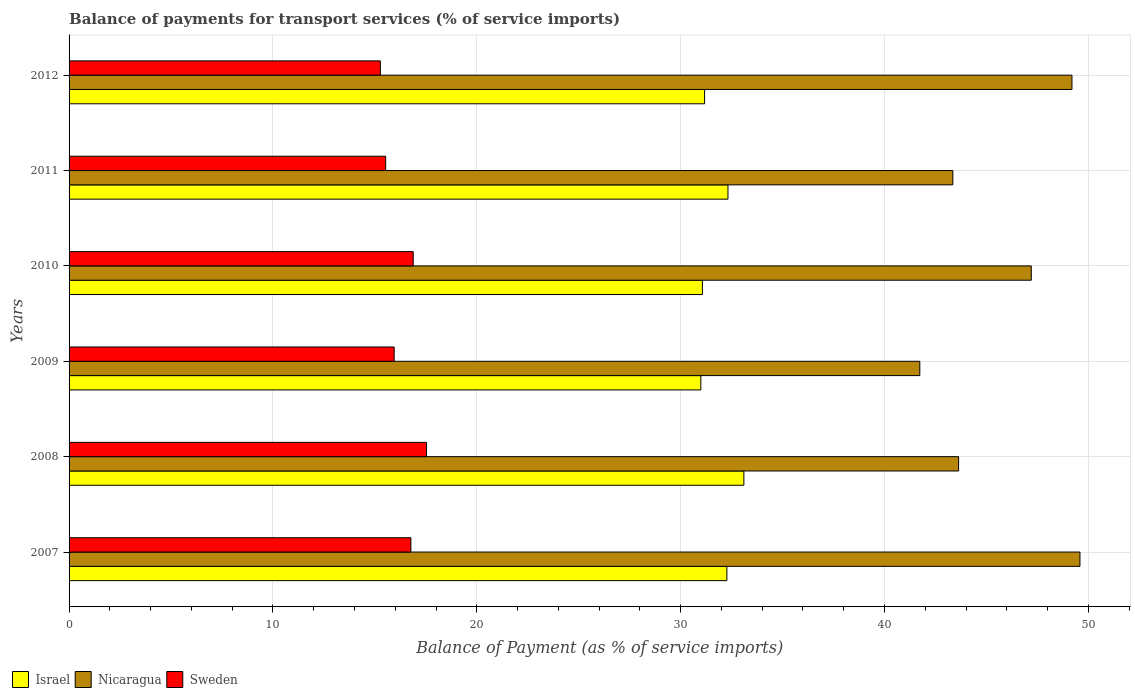How many different coloured bars are there?
Ensure brevity in your answer.  3. Are the number of bars per tick equal to the number of legend labels?
Your response must be concise. Yes. Are the number of bars on each tick of the Y-axis equal?
Give a very brief answer. Yes. How many bars are there on the 3rd tick from the top?
Your answer should be compact. 3. How many bars are there on the 5th tick from the bottom?
Provide a succinct answer. 3. What is the label of the 3rd group of bars from the top?
Offer a terse response. 2010. What is the balance of payments for transport services in Israel in 2010?
Make the answer very short. 31.07. Across all years, what is the maximum balance of payments for transport services in Israel?
Make the answer very short. 33.1. Across all years, what is the minimum balance of payments for transport services in Sweden?
Ensure brevity in your answer.  15.27. In which year was the balance of payments for transport services in Israel maximum?
Make the answer very short. 2008. What is the total balance of payments for transport services in Sweden in the graph?
Ensure brevity in your answer.  97.93. What is the difference between the balance of payments for transport services in Sweden in 2010 and that in 2011?
Make the answer very short. 1.35. What is the difference between the balance of payments for transport services in Nicaragua in 2010 and the balance of payments for transport services in Israel in 2008?
Provide a succinct answer. 14.1. What is the average balance of payments for transport services in Nicaragua per year?
Your response must be concise. 45.78. In the year 2012, what is the difference between the balance of payments for transport services in Nicaragua and balance of payments for transport services in Israel?
Your answer should be very brief. 18.02. In how many years, is the balance of payments for transport services in Nicaragua greater than 6 %?
Offer a terse response. 6. What is the ratio of the balance of payments for transport services in Sweden in 2007 to that in 2011?
Your response must be concise. 1.08. What is the difference between the highest and the second highest balance of payments for transport services in Nicaragua?
Keep it short and to the point. 0.39. What is the difference between the highest and the lowest balance of payments for transport services in Sweden?
Provide a succinct answer. 2.26. Is the sum of the balance of payments for transport services in Sweden in 2008 and 2009 greater than the maximum balance of payments for transport services in Israel across all years?
Make the answer very short. Yes. What does the 1st bar from the top in 2008 represents?
Offer a terse response. Sweden. What does the 2nd bar from the bottom in 2009 represents?
Provide a short and direct response. Nicaragua. Is it the case that in every year, the sum of the balance of payments for transport services in Sweden and balance of payments for transport services in Israel is greater than the balance of payments for transport services in Nicaragua?
Provide a short and direct response. No. How many bars are there?
Keep it short and to the point. 18. Are all the bars in the graph horizontal?
Give a very brief answer. Yes. How many years are there in the graph?
Give a very brief answer. 6. Are the values on the major ticks of X-axis written in scientific E-notation?
Your answer should be compact. No. What is the title of the graph?
Give a very brief answer. Balance of payments for transport services (% of service imports). Does "Thailand" appear as one of the legend labels in the graph?
Make the answer very short. No. What is the label or title of the X-axis?
Your answer should be very brief. Balance of Payment (as % of service imports). What is the Balance of Payment (as % of service imports) of Israel in 2007?
Give a very brief answer. 32.27. What is the Balance of Payment (as % of service imports) in Nicaragua in 2007?
Ensure brevity in your answer.  49.59. What is the Balance of Payment (as % of service imports) of Sweden in 2007?
Your response must be concise. 16.77. What is the Balance of Payment (as % of service imports) in Israel in 2008?
Provide a short and direct response. 33.1. What is the Balance of Payment (as % of service imports) in Nicaragua in 2008?
Keep it short and to the point. 43.63. What is the Balance of Payment (as % of service imports) in Sweden in 2008?
Your response must be concise. 17.54. What is the Balance of Payment (as % of service imports) of Israel in 2009?
Provide a succinct answer. 30.99. What is the Balance of Payment (as % of service imports) of Nicaragua in 2009?
Keep it short and to the point. 41.73. What is the Balance of Payment (as % of service imports) of Sweden in 2009?
Offer a very short reply. 15.95. What is the Balance of Payment (as % of service imports) in Israel in 2010?
Your answer should be very brief. 31.07. What is the Balance of Payment (as % of service imports) in Nicaragua in 2010?
Give a very brief answer. 47.2. What is the Balance of Payment (as % of service imports) in Sweden in 2010?
Provide a succinct answer. 16.88. What is the Balance of Payment (as % of service imports) of Israel in 2011?
Your answer should be compact. 32.32. What is the Balance of Payment (as % of service imports) of Nicaragua in 2011?
Your answer should be very brief. 43.35. What is the Balance of Payment (as % of service imports) in Sweden in 2011?
Provide a succinct answer. 15.53. What is the Balance of Payment (as % of service imports) in Israel in 2012?
Offer a terse response. 31.18. What is the Balance of Payment (as % of service imports) in Nicaragua in 2012?
Keep it short and to the point. 49.2. What is the Balance of Payment (as % of service imports) in Sweden in 2012?
Make the answer very short. 15.27. Across all years, what is the maximum Balance of Payment (as % of service imports) in Israel?
Ensure brevity in your answer.  33.1. Across all years, what is the maximum Balance of Payment (as % of service imports) in Nicaragua?
Give a very brief answer. 49.59. Across all years, what is the maximum Balance of Payment (as % of service imports) of Sweden?
Your answer should be very brief. 17.54. Across all years, what is the minimum Balance of Payment (as % of service imports) of Israel?
Provide a short and direct response. 30.99. Across all years, what is the minimum Balance of Payment (as % of service imports) in Nicaragua?
Provide a short and direct response. 41.73. Across all years, what is the minimum Balance of Payment (as % of service imports) of Sweden?
Offer a terse response. 15.27. What is the total Balance of Payment (as % of service imports) in Israel in the graph?
Provide a short and direct response. 190.92. What is the total Balance of Payment (as % of service imports) in Nicaragua in the graph?
Make the answer very short. 274.7. What is the total Balance of Payment (as % of service imports) in Sweden in the graph?
Provide a short and direct response. 97.93. What is the difference between the Balance of Payment (as % of service imports) in Nicaragua in 2007 and that in 2008?
Your response must be concise. 5.95. What is the difference between the Balance of Payment (as % of service imports) in Sweden in 2007 and that in 2008?
Offer a very short reply. -0.77. What is the difference between the Balance of Payment (as % of service imports) in Israel in 2007 and that in 2009?
Your response must be concise. 1.28. What is the difference between the Balance of Payment (as % of service imports) of Nicaragua in 2007 and that in 2009?
Ensure brevity in your answer.  7.86. What is the difference between the Balance of Payment (as % of service imports) of Sweden in 2007 and that in 2009?
Keep it short and to the point. 0.82. What is the difference between the Balance of Payment (as % of service imports) of Israel in 2007 and that in 2010?
Your answer should be very brief. 1.2. What is the difference between the Balance of Payment (as % of service imports) in Nicaragua in 2007 and that in 2010?
Make the answer very short. 2.39. What is the difference between the Balance of Payment (as % of service imports) in Sweden in 2007 and that in 2010?
Provide a succinct answer. -0.12. What is the difference between the Balance of Payment (as % of service imports) in Israel in 2007 and that in 2011?
Give a very brief answer. -0.05. What is the difference between the Balance of Payment (as % of service imports) in Nicaragua in 2007 and that in 2011?
Give a very brief answer. 6.24. What is the difference between the Balance of Payment (as % of service imports) in Sweden in 2007 and that in 2011?
Your answer should be very brief. 1.24. What is the difference between the Balance of Payment (as % of service imports) in Israel in 2007 and that in 2012?
Your response must be concise. 1.09. What is the difference between the Balance of Payment (as % of service imports) in Nicaragua in 2007 and that in 2012?
Offer a terse response. 0.39. What is the difference between the Balance of Payment (as % of service imports) of Sweden in 2007 and that in 2012?
Your answer should be compact. 1.5. What is the difference between the Balance of Payment (as % of service imports) in Israel in 2008 and that in 2009?
Provide a succinct answer. 2.11. What is the difference between the Balance of Payment (as % of service imports) of Nicaragua in 2008 and that in 2009?
Offer a terse response. 1.9. What is the difference between the Balance of Payment (as % of service imports) in Sweden in 2008 and that in 2009?
Your answer should be compact. 1.59. What is the difference between the Balance of Payment (as % of service imports) of Israel in 2008 and that in 2010?
Give a very brief answer. 2.04. What is the difference between the Balance of Payment (as % of service imports) in Nicaragua in 2008 and that in 2010?
Your response must be concise. -3.57. What is the difference between the Balance of Payment (as % of service imports) of Sweden in 2008 and that in 2010?
Ensure brevity in your answer.  0.65. What is the difference between the Balance of Payment (as % of service imports) of Israel in 2008 and that in 2011?
Offer a terse response. 0.78. What is the difference between the Balance of Payment (as % of service imports) of Nicaragua in 2008 and that in 2011?
Make the answer very short. 0.28. What is the difference between the Balance of Payment (as % of service imports) of Sweden in 2008 and that in 2011?
Your answer should be very brief. 2. What is the difference between the Balance of Payment (as % of service imports) in Israel in 2008 and that in 2012?
Offer a very short reply. 1.93. What is the difference between the Balance of Payment (as % of service imports) in Nicaragua in 2008 and that in 2012?
Make the answer very short. -5.56. What is the difference between the Balance of Payment (as % of service imports) in Sweden in 2008 and that in 2012?
Provide a succinct answer. 2.26. What is the difference between the Balance of Payment (as % of service imports) in Israel in 2009 and that in 2010?
Your response must be concise. -0.08. What is the difference between the Balance of Payment (as % of service imports) of Nicaragua in 2009 and that in 2010?
Your response must be concise. -5.47. What is the difference between the Balance of Payment (as % of service imports) in Sweden in 2009 and that in 2010?
Keep it short and to the point. -0.93. What is the difference between the Balance of Payment (as % of service imports) of Israel in 2009 and that in 2011?
Your response must be concise. -1.33. What is the difference between the Balance of Payment (as % of service imports) in Nicaragua in 2009 and that in 2011?
Ensure brevity in your answer.  -1.62. What is the difference between the Balance of Payment (as % of service imports) in Sweden in 2009 and that in 2011?
Keep it short and to the point. 0.42. What is the difference between the Balance of Payment (as % of service imports) in Israel in 2009 and that in 2012?
Your response must be concise. -0.18. What is the difference between the Balance of Payment (as % of service imports) of Nicaragua in 2009 and that in 2012?
Offer a very short reply. -7.46. What is the difference between the Balance of Payment (as % of service imports) of Sweden in 2009 and that in 2012?
Ensure brevity in your answer.  0.68. What is the difference between the Balance of Payment (as % of service imports) in Israel in 2010 and that in 2011?
Offer a very short reply. -1.25. What is the difference between the Balance of Payment (as % of service imports) of Nicaragua in 2010 and that in 2011?
Offer a very short reply. 3.85. What is the difference between the Balance of Payment (as % of service imports) of Sweden in 2010 and that in 2011?
Give a very brief answer. 1.35. What is the difference between the Balance of Payment (as % of service imports) in Israel in 2010 and that in 2012?
Make the answer very short. -0.11. What is the difference between the Balance of Payment (as % of service imports) of Nicaragua in 2010 and that in 2012?
Ensure brevity in your answer.  -2. What is the difference between the Balance of Payment (as % of service imports) in Sweden in 2010 and that in 2012?
Your response must be concise. 1.61. What is the difference between the Balance of Payment (as % of service imports) in Israel in 2011 and that in 2012?
Make the answer very short. 1.15. What is the difference between the Balance of Payment (as % of service imports) of Nicaragua in 2011 and that in 2012?
Keep it short and to the point. -5.84. What is the difference between the Balance of Payment (as % of service imports) in Sweden in 2011 and that in 2012?
Provide a short and direct response. 0.26. What is the difference between the Balance of Payment (as % of service imports) of Israel in 2007 and the Balance of Payment (as % of service imports) of Nicaragua in 2008?
Your response must be concise. -11.37. What is the difference between the Balance of Payment (as % of service imports) of Israel in 2007 and the Balance of Payment (as % of service imports) of Sweden in 2008?
Give a very brief answer. 14.73. What is the difference between the Balance of Payment (as % of service imports) in Nicaragua in 2007 and the Balance of Payment (as % of service imports) in Sweden in 2008?
Give a very brief answer. 32.05. What is the difference between the Balance of Payment (as % of service imports) in Israel in 2007 and the Balance of Payment (as % of service imports) in Nicaragua in 2009?
Offer a terse response. -9.46. What is the difference between the Balance of Payment (as % of service imports) in Israel in 2007 and the Balance of Payment (as % of service imports) in Sweden in 2009?
Make the answer very short. 16.32. What is the difference between the Balance of Payment (as % of service imports) in Nicaragua in 2007 and the Balance of Payment (as % of service imports) in Sweden in 2009?
Make the answer very short. 33.64. What is the difference between the Balance of Payment (as % of service imports) in Israel in 2007 and the Balance of Payment (as % of service imports) in Nicaragua in 2010?
Offer a very short reply. -14.93. What is the difference between the Balance of Payment (as % of service imports) in Israel in 2007 and the Balance of Payment (as % of service imports) in Sweden in 2010?
Provide a succinct answer. 15.39. What is the difference between the Balance of Payment (as % of service imports) of Nicaragua in 2007 and the Balance of Payment (as % of service imports) of Sweden in 2010?
Provide a short and direct response. 32.71. What is the difference between the Balance of Payment (as % of service imports) of Israel in 2007 and the Balance of Payment (as % of service imports) of Nicaragua in 2011?
Offer a very short reply. -11.08. What is the difference between the Balance of Payment (as % of service imports) of Israel in 2007 and the Balance of Payment (as % of service imports) of Sweden in 2011?
Provide a short and direct response. 16.74. What is the difference between the Balance of Payment (as % of service imports) of Nicaragua in 2007 and the Balance of Payment (as % of service imports) of Sweden in 2011?
Offer a very short reply. 34.06. What is the difference between the Balance of Payment (as % of service imports) in Israel in 2007 and the Balance of Payment (as % of service imports) in Nicaragua in 2012?
Ensure brevity in your answer.  -16.93. What is the difference between the Balance of Payment (as % of service imports) of Israel in 2007 and the Balance of Payment (as % of service imports) of Sweden in 2012?
Ensure brevity in your answer.  17. What is the difference between the Balance of Payment (as % of service imports) of Nicaragua in 2007 and the Balance of Payment (as % of service imports) of Sweden in 2012?
Ensure brevity in your answer.  34.32. What is the difference between the Balance of Payment (as % of service imports) of Israel in 2008 and the Balance of Payment (as % of service imports) of Nicaragua in 2009?
Ensure brevity in your answer.  -8.63. What is the difference between the Balance of Payment (as % of service imports) of Israel in 2008 and the Balance of Payment (as % of service imports) of Sweden in 2009?
Offer a terse response. 17.15. What is the difference between the Balance of Payment (as % of service imports) in Nicaragua in 2008 and the Balance of Payment (as % of service imports) in Sweden in 2009?
Your answer should be very brief. 27.69. What is the difference between the Balance of Payment (as % of service imports) of Israel in 2008 and the Balance of Payment (as % of service imports) of Nicaragua in 2010?
Offer a terse response. -14.1. What is the difference between the Balance of Payment (as % of service imports) in Israel in 2008 and the Balance of Payment (as % of service imports) in Sweden in 2010?
Keep it short and to the point. 16.22. What is the difference between the Balance of Payment (as % of service imports) of Nicaragua in 2008 and the Balance of Payment (as % of service imports) of Sweden in 2010?
Your answer should be compact. 26.75. What is the difference between the Balance of Payment (as % of service imports) of Israel in 2008 and the Balance of Payment (as % of service imports) of Nicaragua in 2011?
Ensure brevity in your answer.  -10.25. What is the difference between the Balance of Payment (as % of service imports) in Israel in 2008 and the Balance of Payment (as % of service imports) in Sweden in 2011?
Your answer should be very brief. 17.57. What is the difference between the Balance of Payment (as % of service imports) in Nicaragua in 2008 and the Balance of Payment (as % of service imports) in Sweden in 2011?
Provide a short and direct response. 28.1. What is the difference between the Balance of Payment (as % of service imports) of Israel in 2008 and the Balance of Payment (as % of service imports) of Nicaragua in 2012?
Offer a very short reply. -16.09. What is the difference between the Balance of Payment (as % of service imports) in Israel in 2008 and the Balance of Payment (as % of service imports) in Sweden in 2012?
Your response must be concise. 17.83. What is the difference between the Balance of Payment (as % of service imports) in Nicaragua in 2008 and the Balance of Payment (as % of service imports) in Sweden in 2012?
Provide a short and direct response. 28.36. What is the difference between the Balance of Payment (as % of service imports) of Israel in 2009 and the Balance of Payment (as % of service imports) of Nicaragua in 2010?
Offer a very short reply. -16.21. What is the difference between the Balance of Payment (as % of service imports) in Israel in 2009 and the Balance of Payment (as % of service imports) in Sweden in 2010?
Make the answer very short. 14.11. What is the difference between the Balance of Payment (as % of service imports) in Nicaragua in 2009 and the Balance of Payment (as % of service imports) in Sweden in 2010?
Offer a very short reply. 24.85. What is the difference between the Balance of Payment (as % of service imports) of Israel in 2009 and the Balance of Payment (as % of service imports) of Nicaragua in 2011?
Your answer should be compact. -12.36. What is the difference between the Balance of Payment (as % of service imports) of Israel in 2009 and the Balance of Payment (as % of service imports) of Sweden in 2011?
Keep it short and to the point. 15.46. What is the difference between the Balance of Payment (as % of service imports) in Nicaragua in 2009 and the Balance of Payment (as % of service imports) in Sweden in 2011?
Provide a succinct answer. 26.2. What is the difference between the Balance of Payment (as % of service imports) of Israel in 2009 and the Balance of Payment (as % of service imports) of Nicaragua in 2012?
Make the answer very short. -18.21. What is the difference between the Balance of Payment (as % of service imports) in Israel in 2009 and the Balance of Payment (as % of service imports) in Sweden in 2012?
Your response must be concise. 15.72. What is the difference between the Balance of Payment (as % of service imports) in Nicaragua in 2009 and the Balance of Payment (as % of service imports) in Sweden in 2012?
Your response must be concise. 26.46. What is the difference between the Balance of Payment (as % of service imports) of Israel in 2010 and the Balance of Payment (as % of service imports) of Nicaragua in 2011?
Ensure brevity in your answer.  -12.29. What is the difference between the Balance of Payment (as % of service imports) of Israel in 2010 and the Balance of Payment (as % of service imports) of Sweden in 2011?
Offer a terse response. 15.54. What is the difference between the Balance of Payment (as % of service imports) in Nicaragua in 2010 and the Balance of Payment (as % of service imports) in Sweden in 2011?
Your answer should be compact. 31.67. What is the difference between the Balance of Payment (as % of service imports) of Israel in 2010 and the Balance of Payment (as % of service imports) of Nicaragua in 2012?
Ensure brevity in your answer.  -18.13. What is the difference between the Balance of Payment (as % of service imports) in Israel in 2010 and the Balance of Payment (as % of service imports) in Sweden in 2012?
Ensure brevity in your answer.  15.8. What is the difference between the Balance of Payment (as % of service imports) in Nicaragua in 2010 and the Balance of Payment (as % of service imports) in Sweden in 2012?
Keep it short and to the point. 31.93. What is the difference between the Balance of Payment (as % of service imports) in Israel in 2011 and the Balance of Payment (as % of service imports) in Nicaragua in 2012?
Keep it short and to the point. -16.87. What is the difference between the Balance of Payment (as % of service imports) in Israel in 2011 and the Balance of Payment (as % of service imports) in Sweden in 2012?
Your response must be concise. 17.05. What is the difference between the Balance of Payment (as % of service imports) in Nicaragua in 2011 and the Balance of Payment (as % of service imports) in Sweden in 2012?
Your answer should be compact. 28.08. What is the average Balance of Payment (as % of service imports) in Israel per year?
Keep it short and to the point. 31.82. What is the average Balance of Payment (as % of service imports) in Nicaragua per year?
Your answer should be compact. 45.78. What is the average Balance of Payment (as % of service imports) of Sweden per year?
Make the answer very short. 16.32. In the year 2007, what is the difference between the Balance of Payment (as % of service imports) in Israel and Balance of Payment (as % of service imports) in Nicaragua?
Offer a very short reply. -17.32. In the year 2007, what is the difference between the Balance of Payment (as % of service imports) in Israel and Balance of Payment (as % of service imports) in Sweden?
Your response must be concise. 15.5. In the year 2007, what is the difference between the Balance of Payment (as % of service imports) in Nicaragua and Balance of Payment (as % of service imports) in Sweden?
Ensure brevity in your answer.  32.82. In the year 2008, what is the difference between the Balance of Payment (as % of service imports) of Israel and Balance of Payment (as % of service imports) of Nicaragua?
Ensure brevity in your answer.  -10.53. In the year 2008, what is the difference between the Balance of Payment (as % of service imports) of Israel and Balance of Payment (as % of service imports) of Sweden?
Provide a succinct answer. 15.57. In the year 2008, what is the difference between the Balance of Payment (as % of service imports) of Nicaragua and Balance of Payment (as % of service imports) of Sweden?
Ensure brevity in your answer.  26.1. In the year 2009, what is the difference between the Balance of Payment (as % of service imports) of Israel and Balance of Payment (as % of service imports) of Nicaragua?
Your answer should be very brief. -10.74. In the year 2009, what is the difference between the Balance of Payment (as % of service imports) of Israel and Balance of Payment (as % of service imports) of Sweden?
Offer a terse response. 15.04. In the year 2009, what is the difference between the Balance of Payment (as % of service imports) of Nicaragua and Balance of Payment (as % of service imports) of Sweden?
Your answer should be very brief. 25.79. In the year 2010, what is the difference between the Balance of Payment (as % of service imports) of Israel and Balance of Payment (as % of service imports) of Nicaragua?
Your answer should be compact. -16.13. In the year 2010, what is the difference between the Balance of Payment (as % of service imports) of Israel and Balance of Payment (as % of service imports) of Sweden?
Offer a terse response. 14.18. In the year 2010, what is the difference between the Balance of Payment (as % of service imports) of Nicaragua and Balance of Payment (as % of service imports) of Sweden?
Your answer should be very brief. 30.32. In the year 2011, what is the difference between the Balance of Payment (as % of service imports) of Israel and Balance of Payment (as % of service imports) of Nicaragua?
Provide a short and direct response. -11.03. In the year 2011, what is the difference between the Balance of Payment (as % of service imports) in Israel and Balance of Payment (as % of service imports) in Sweden?
Give a very brief answer. 16.79. In the year 2011, what is the difference between the Balance of Payment (as % of service imports) of Nicaragua and Balance of Payment (as % of service imports) of Sweden?
Make the answer very short. 27.82. In the year 2012, what is the difference between the Balance of Payment (as % of service imports) of Israel and Balance of Payment (as % of service imports) of Nicaragua?
Offer a very short reply. -18.02. In the year 2012, what is the difference between the Balance of Payment (as % of service imports) of Israel and Balance of Payment (as % of service imports) of Sweden?
Make the answer very short. 15.9. In the year 2012, what is the difference between the Balance of Payment (as % of service imports) of Nicaragua and Balance of Payment (as % of service imports) of Sweden?
Provide a succinct answer. 33.93. What is the ratio of the Balance of Payment (as % of service imports) in Israel in 2007 to that in 2008?
Your answer should be compact. 0.97. What is the ratio of the Balance of Payment (as % of service imports) in Nicaragua in 2007 to that in 2008?
Offer a very short reply. 1.14. What is the ratio of the Balance of Payment (as % of service imports) of Sweden in 2007 to that in 2008?
Your answer should be compact. 0.96. What is the ratio of the Balance of Payment (as % of service imports) in Israel in 2007 to that in 2009?
Keep it short and to the point. 1.04. What is the ratio of the Balance of Payment (as % of service imports) of Nicaragua in 2007 to that in 2009?
Provide a short and direct response. 1.19. What is the ratio of the Balance of Payment (as % of service imports) in Sweden in 2007 to that in 2009?
Offer a very short reply. 1.05. What is the ratio of the Balance of Payment (as % of service imports) in Israel in 2007 to that in 2010?
Keep it short and to the point. 1.04. What is the ratio of the Balance of Payment (as % of service imports) in Nicaragua in 2007 to that in 2010?
Ensure brevity in your answer.  1.05. What is the ratio of the Balance of Payment (as % of service imports) in Nicaragua in 2007 to that in 2011?
Your answer should be very brief. 1.14. What is the ratio of the Balance of Payment (as % of service imports) of Sweden in 2007 to that in 2011?
Keep it short and to the point. 1.08. What is the ratio of the Balance of Payment (as % of service imports) of Israel in 2007 to that in 2012?
Ensure brevity in your answer.  1.04. What is the ratio of the Balance of Payment (as % of service imports) in Nicaragua in 2007 to that in 2012?
Offer a terse response. 1.01. What is the ratio of the Balance of Payment (as % of service imports) of Sweden in 2007 to that in 2012?
Your answer should be compact. 1.1. What is the ratio of the Balance of Payment (as % of service imports) of Israel in 2008 to that in 2009?
Offer a terse response. 1.07. What is the ratio of the Balance of Payment (as % of service imports) in Nicaragua in 2008 to that in 2009?
Make the answer very short. 1.05. What is the ratio of the Balance of Payment (as % of service imports) of Sweden in 2008 to that in 2009?
Offer a terse response. 1.1. What is the ratio of the Balance of Payment (as % of service imports) of Israel in 2008 to that in 2010?
Give a very brief answer. 1.07. What is the ratio of the Balance of Payment (as % of service imports) in Nicaragua in 2008 to that in 2010?
Offer a very short reply. 0.92. What is the ratio of the Balance of Payment (as % of service imports) of Sweden in 2008 to that in 2010?
Your answer should be compact. 1.04. What is the ratio of the Balance of Payment (as % of service imports) of Israel in 2008 to that in 2011?
Keep it short and to the point. 1.02. What is the ratio of the Balance of Payment (as % of service imports) in Sweden in 2008 to that in 2011?
Provide a short and direct response. 1.13. What is the ratio of the Balance of Payment (as % of service imports) in Israel in 2008 to that in 2012?
Offer a terse response. 1.06. What is the ratio of the Balance of Payment (as % of service imports) of Nicaragua in 2008 to that in 2012?
Make the answer very short. 0.89. What is the ratio of the Balance of Payment (as % of service imports) of Sweden in 2008 to that in 2012?
Provide a short and direct response. 1.15. What is the ratio of the Balance of Payment (as % of service imports) of Nicaragua in 2009 to that in 2010?
Ensure brevity in your answer.  0.88. What is the ratio of the Balance of Payment (as % of service imports) of Sweden in 2009 to that in 2010?
Your response must be concise. 0.94. What is the ratio of the Balance of Payment (as % of service imports) of Israel in 2009 to that in 2011?
Provide a succinct answer. 0.96. What is the ratio of the Balance of Payment (as % of service imports) of Nicaragua in 2009 to that in 2011?
Offer a very short reply. 0.96. What is the ratio of the Balance of Payment (as % of service imports) of Sweden in 2009 to that in 2011?
Offer a terse response. 1.03. What is the ratio of the Balance of Payment (as % of service imports) in Israel in 2009 to that in 2012?
Offer a terse response. 0.99. What is the ratio of the Balance of Payment (as % of service imports) of Nicaragua in 2009 to that in 2012?
Make the answer very short. 0.85. What is the ratio of the Balance of Payment (as % of service imports) in Sweden in 2009 to that in 2012?
Your response must be concise. 1.04. What is the ratio of the Balance of Payment (as % of service imports) in Israel in 2010 to that in 2011?
Give a very brief answer. 0.96. What is the ratio of the Balance of Payment (as % of service imports) of Nicaragua in 2010 to that in 2011?
Offer a terse response. 1.09. What is the ratio of the Balance of Payment (as % of service imports) in Sweden in 2010 to that in 2011?
Keep it short and to the point. 1.09. What is the ratio of the Balance of Payment (as % of service imports) of Nicaragua in 2010 to that in 2012?
Your answer should be compact. 0.96. What is the ratio of the Balance of Payment (as % of service imports) of Sweden in 2010 to that in 2012?
Ensure brevity in your answer.  1.11. What is the ratio of the Balance of Payment (as % of service imports) of Israel in 2011 to that in 2012?
Give a very brief answer. 1.04. What is the ratio of the Balance of Payment (as % of service imports) in Nicaragua in 2011 to that in 2012?
Your answer should be very brief. 0.88. What is the difference between the highest and the second highest Balance of Payment (as % of service imports) of Israel?
Give a very brief answer. 0.78. What is the difference between the highest and the second highest Balance of Payment (as % of service imports) in Nicaragua?
Your answer should be compact. 0.39. What is the difference between the highest and the second highest Balance of Payment (as % of service imports) of Sweden?
Give a very brief answer. 0.65. What is the difference between the highest and the lowest Balance of Payment (as % of service imports) in Israel?
Make the answer very short. 2.11. What is the difference between the highest and the lowest Balance of Payment (as % of service imports) in Nicaragua?
Provide a succinct answer. 7.86. What is the difference between the highest and the lowest Balance of Payment (as % of service imports) of Sweden?
Provide a short and direct response. 2.26. 